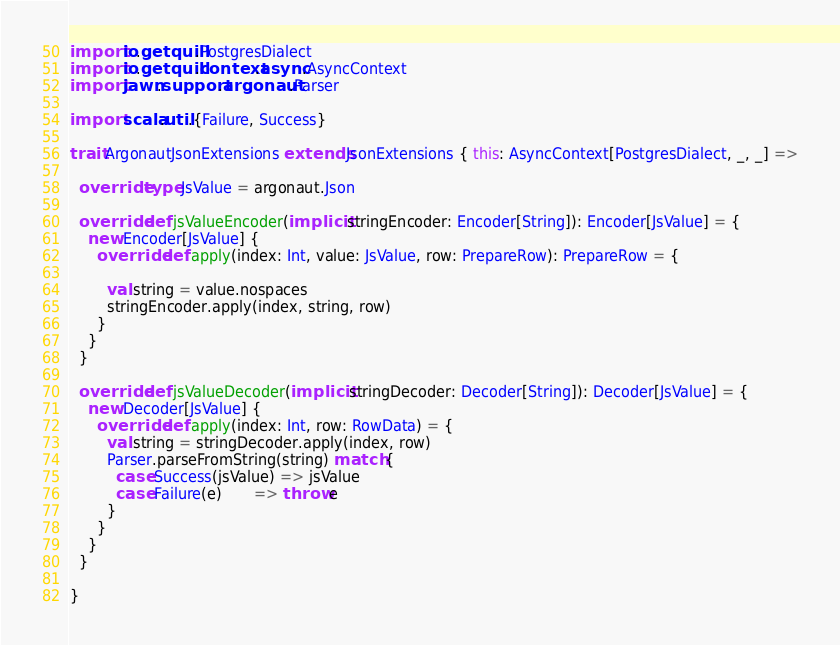Convert code to text. <code><loc_0><loc_0><loc_500><loc_500><_Scala_>import io.getquill.PostgresDialect
import io.getquill.context.async.AsyncContext
import jawn.support.argonaut.Parser

import scala.util.{Failure, Success}

trait ArgonautJsonExtensions extends JsonExtensions { this: AsyncContext[PostgresDialect, _, _] =>

  override type JsValue = argonaut.Json

  override def jsValueEncoder(implicit stringEncoder: Encoder[String]): Encoder[JsValue] = {
    new Encoder[JsValue] {
      override def apply(index: Int, value: JsValue, row: PrepareRow): PrepareRow = {

        val string = value.nospaces
        stringEncoder.apply(index, string, row)
      }
    }
  }

  override def jsValueDecoder(implicit stringDecoder: Decoder[String]): Decoder[JsValue] = {
    new Decoder[JsValue] {
      override def apply(index: Int, row: RowData) = {
        val string = stringDecoder.apply(index, row)
        Parser.parseFromString(string) match {
          case Success(jsValue) => jsValue
          case Failure(e)       => throw e
        }
      }
    }
  }

}
</code> 